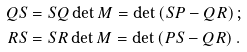Convert formula to latex. <formula><loc_0><loc_0><loc_500><loc_500>Q S & = S Q \det M = \det \left ( S P - Q R \right ) ; \\ R S & = S R \det M = \det \left ( P S - Q R \right ) .</formula> 